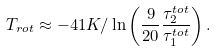<formula> <loc_0><loc_0><loc_500><loc_500>T _ { r o t } \approx - 4 1 K / \ln \left ( \frac { 9 } { 2 0 } \frac { \tau _ { 2 } ^ { t o t } } { \tau _ { 1 } ^ { t o t } } \right ) .</formula> 